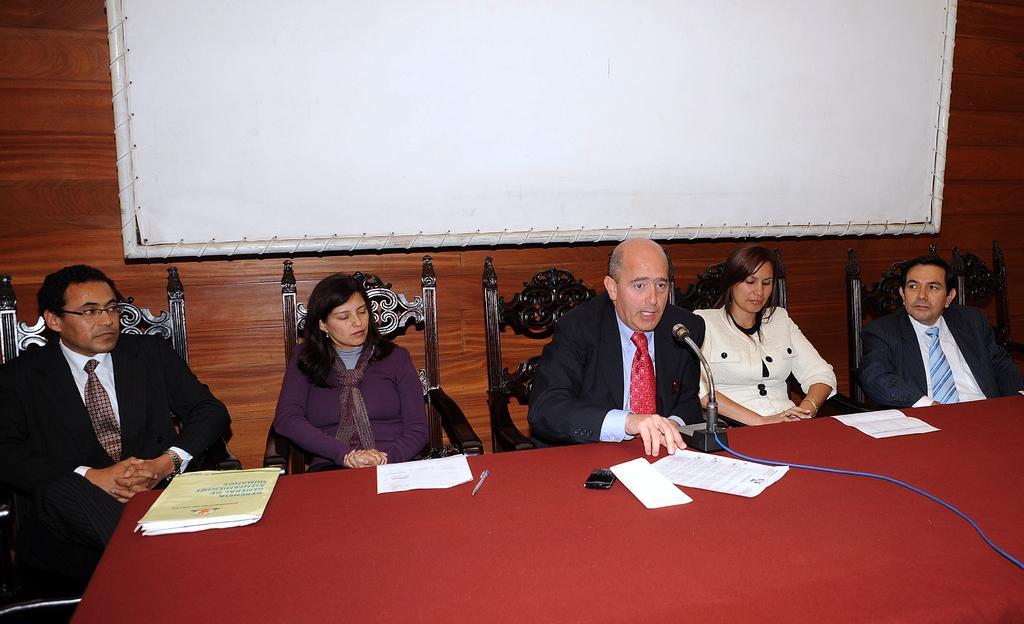Please provide a concise description of this image. In this picture I can see there are few people sitting on the chairs and there is a table here and in the backdrop there is a screen and a wooden wall. 